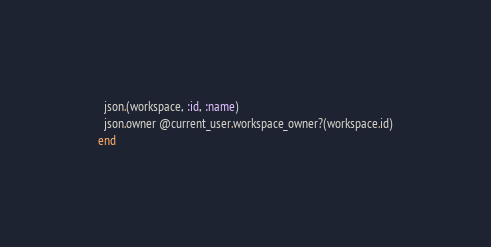<code> <loc_0><loc_0><loc_500><loc_500><_Ruby_>  json.(workspace, :id, :name)
  json.owner @current_user.workspace_owner?(workspace.id)
end
</code> 